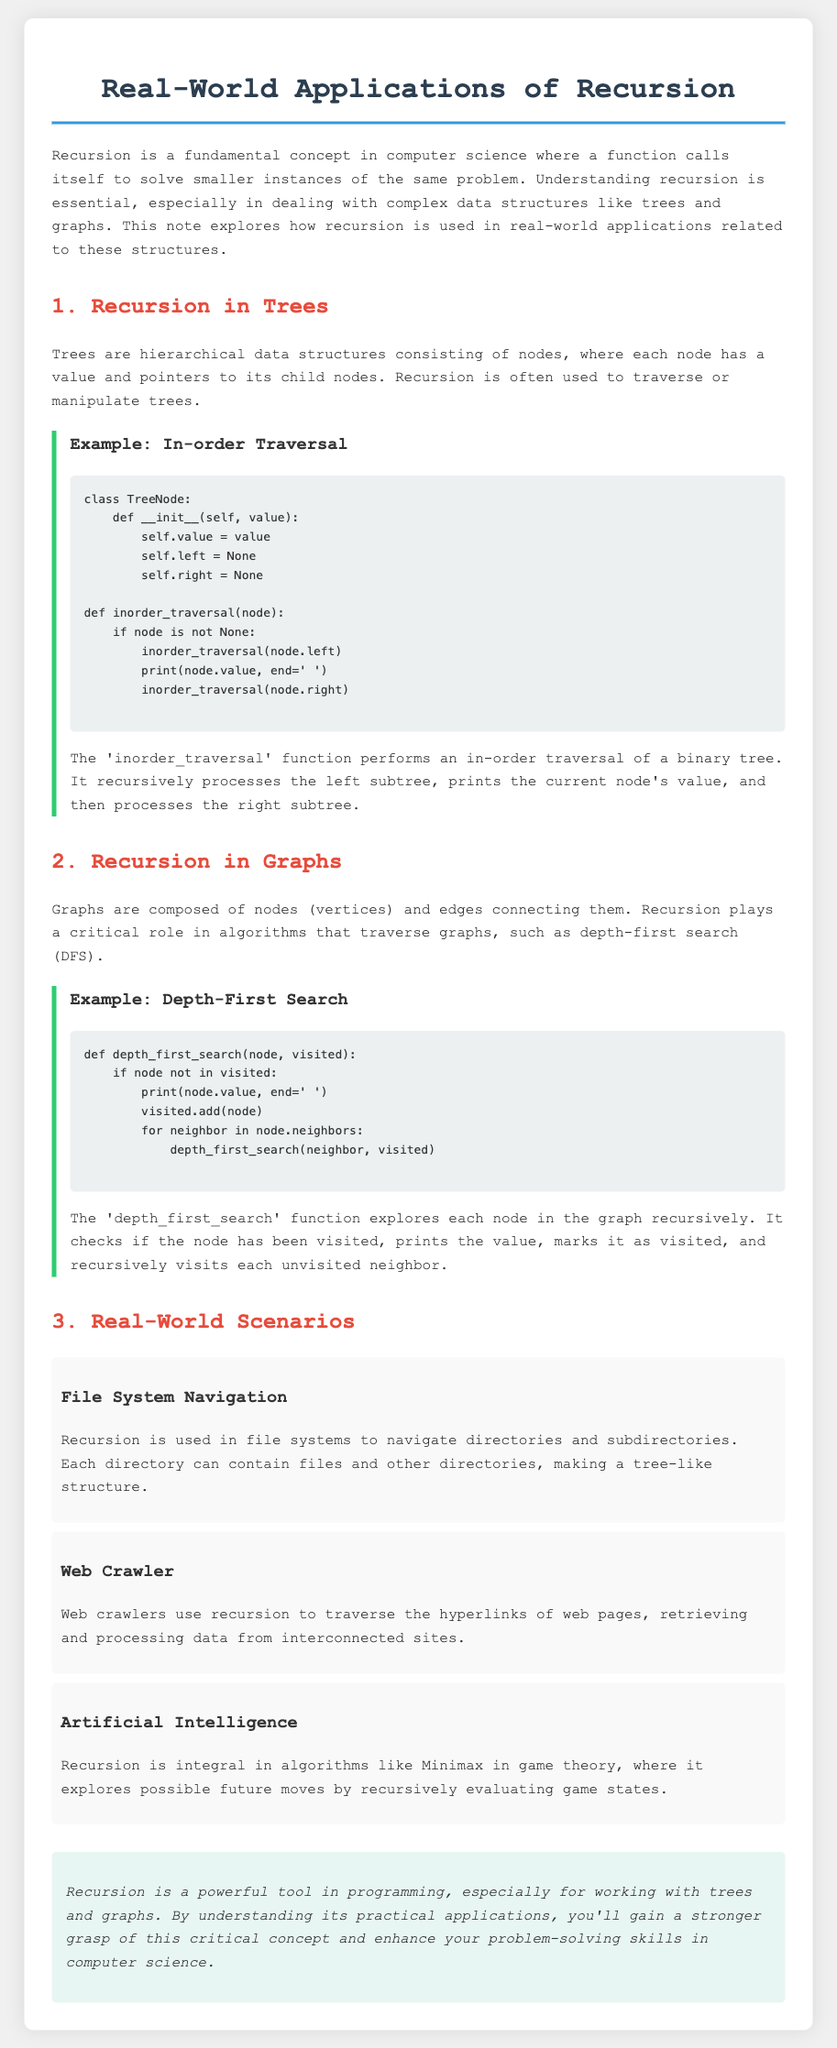What is recursion? Recursion is a fundamental concept in computer science where a function calls itself to solve smaller instances of the same problem.
Answer: a function calls itself What traversal method is used in the tree example? The document discusses a method for traversing binary trees known as in-order traversal.
Answer: in-order traversal What data structure is utilized in the depth-first search example? The depth-first search example works with graphs, which are composed of nodes and edges.
Answer: graphs Name one real-world scenario where recursion is applied. The document mentions several scenarios, including file system navigation, web crawlers, and artificial intelligence.
Answer: file system navigation What is the function of depth-first search in graphs? The depth-first search function explores each node in the graph recursively to visit unvisited neighbors.
Answer: explores each node Which programming concept is mentioned as integral in artificial intelligence algorithms? The note indicates that recursion is integral to algorithms like Minimax in game theory.
Answer: recursion How many examples of real-world scenarios are mentioned? The document lists three specific real-world applications of recursion.
Answer: three What programming language is used in the examples? The code examples in the document use the Python programming language.
Answer: Python What type of search algorithm is illustrated in the graph section? The algorithm illustrated for graphs is depth-first search.
Answer: depth-first search 